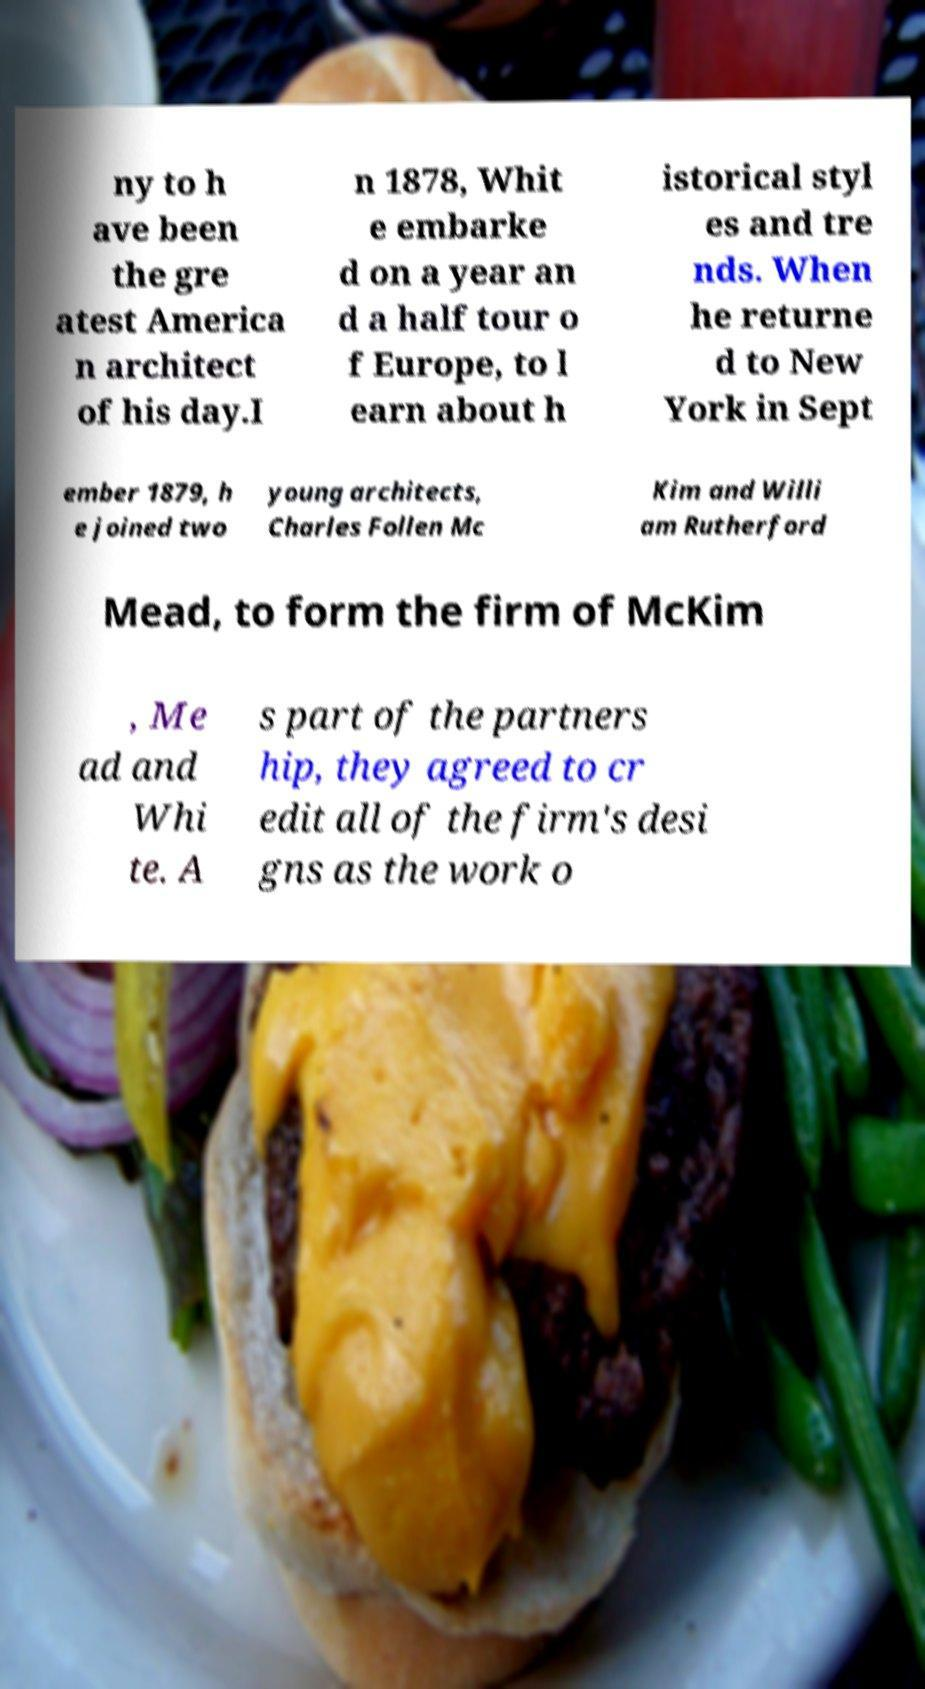What messages or text are displayed in this image? I need them in a readable, typed format. ny to h ave been the gre atest America n architect of his day.I n 1878, Whit e embarke d on a year an d a half tour o f Europe, to l earn about h istorical styl es and tre nds. When he returne d to New York in Sept ember 1879, h e joined two young architects, Charles Follen Mc Kim and Willi am Rutherford Mead, to form the firm of McKim , Me ad and Whi te. A s part of the partners hip, they agreed to cr edit all of the firm's desi gns as the work o 